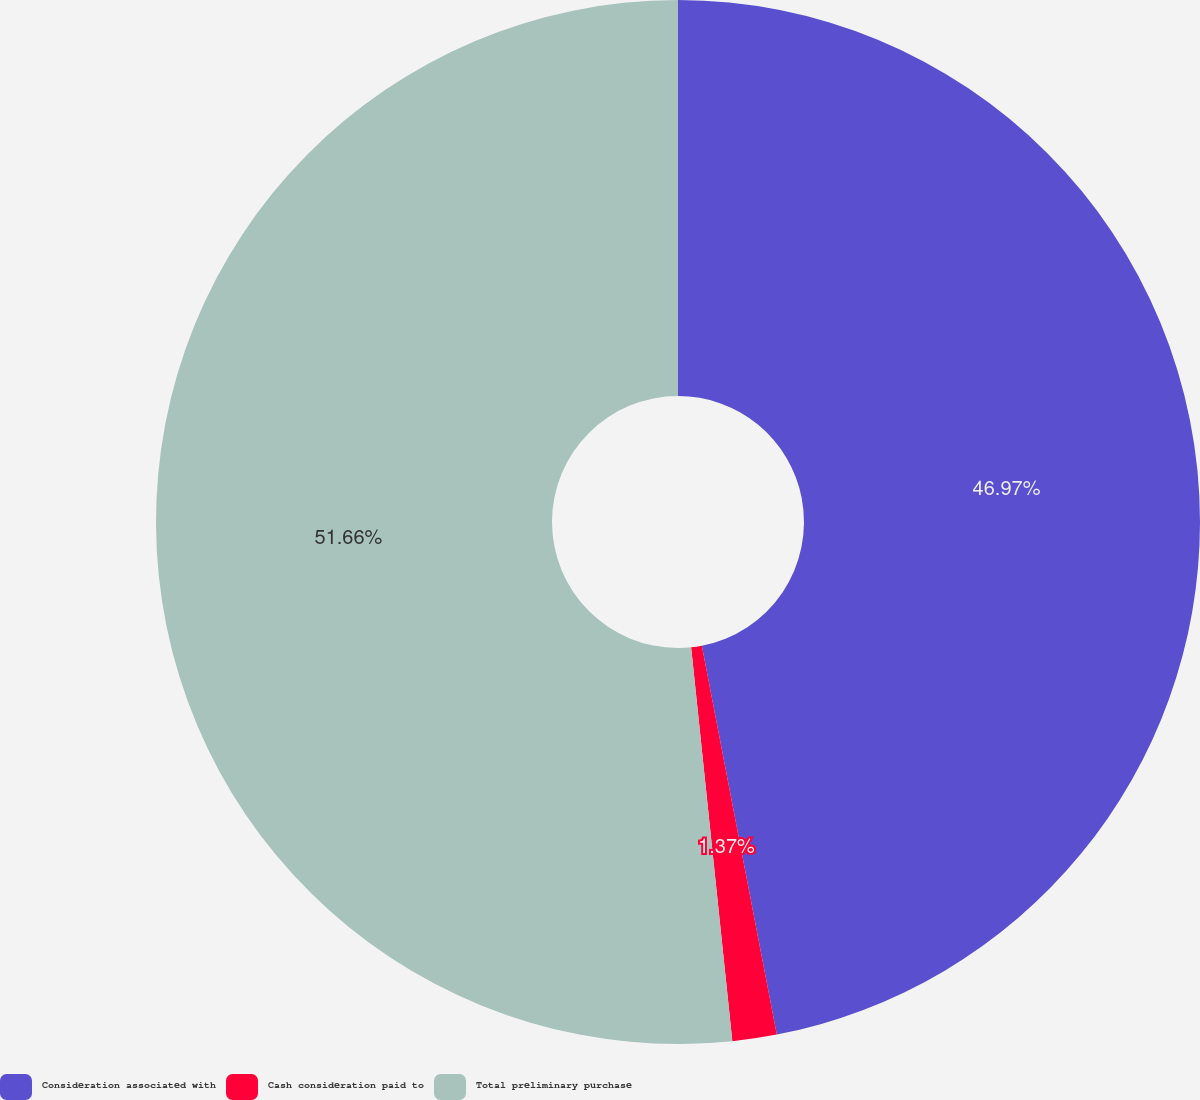<chart> <loc_0><loc_0><loc_500><loc_500><pie_chart><fcel>Consideration associated with<fcel>Cash consideration paid to<fcel>Total preliminary purchase<nl><fcel>46.97%<fcel>1.37%<fcel>51.66%<nl></chart> 